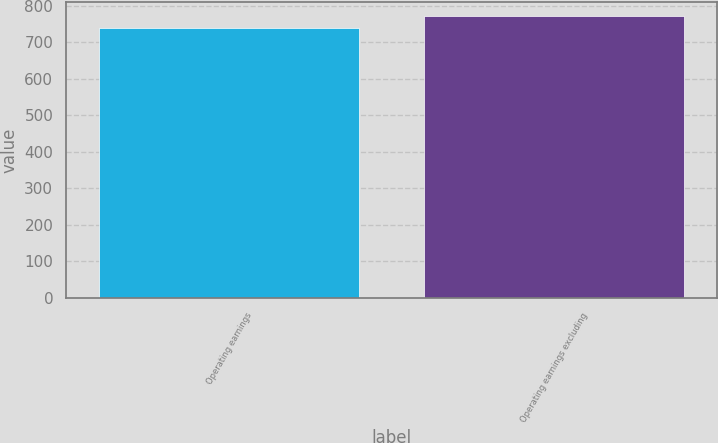<chart> <loc_0><loc_0><loc_500><loc_500><bar_chart><fcel>Operating earnings<fcel>Operating earnings excluding<nl><fcel>740<fcel>771<nl></chart> 